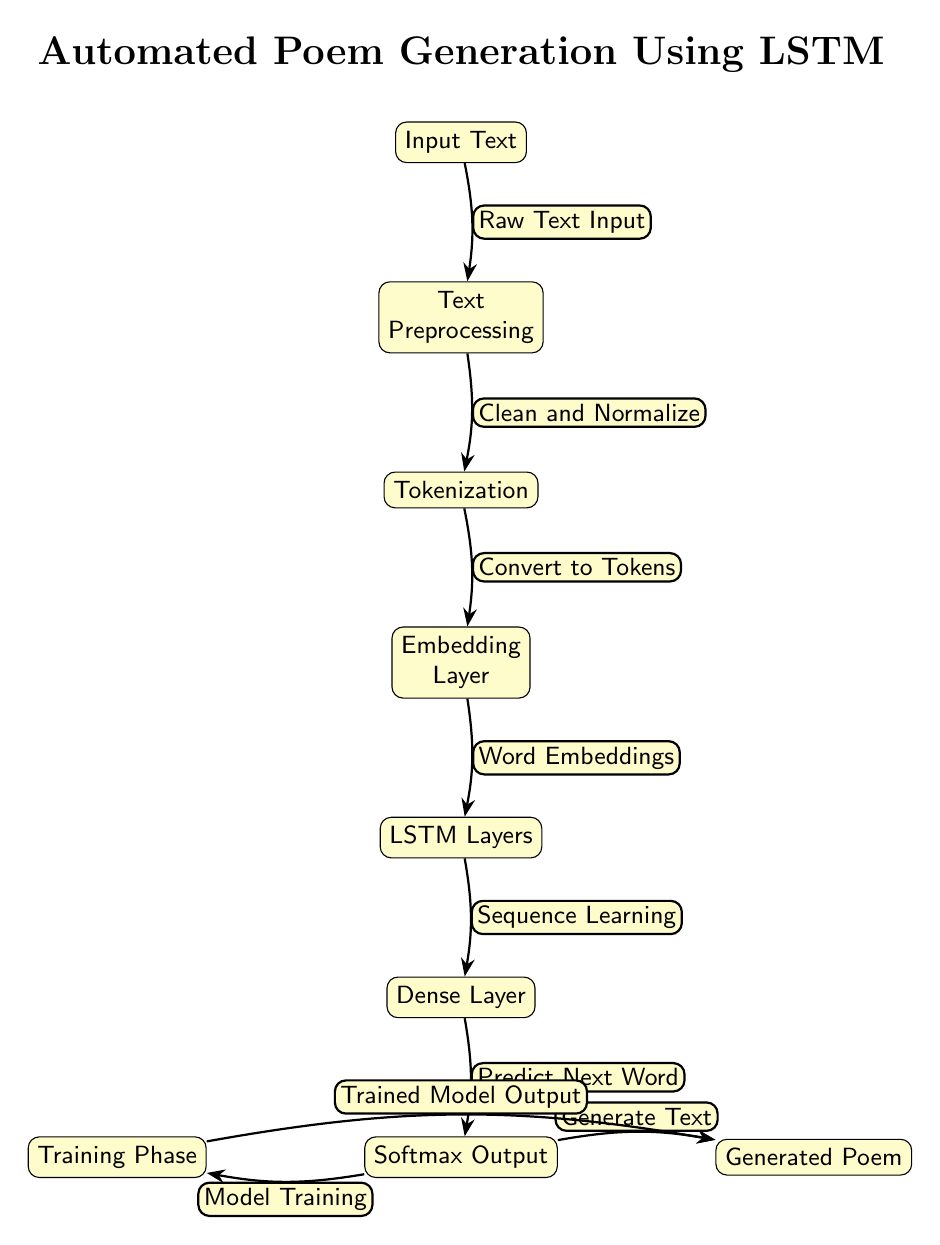What is the first step in the diagram? The diagram shows the flow starting from the "Input Text" node at the top as the first step in the process.
Answer: Input Text How many nodes are present in the diagram? Counting each distinct node from "Input Text" to "Generated Poem", there are a total of 7 nodes in the diagram.
Answer: 7 What is the output of the dense layer? The dense layer's output is directed towards the "Softmax Output" node, which predicts the next word based on the sequence processed.
Answer: Softmax Output What does the training phase output? According to the diagram, the training phase produces the "Trained Model Output" which is necessary for generating the poem.
Answer: Trained Model Output What is the relationship between the embedding layer and the lstm layers? The arrow connecting the embedding layer to the lstm layers indicates that the output of the embedding layer is used as input for the lstm layers, hence showing a flow of data.
Answer: Word Embeddings What is the final result of the automated poem generation process? The final result, as indicated by the diagram, is the "Generated Poem" which concludes the sequence of processing steps.
Answer: Generated Poem What action is taken during the text preprocessing step? The text preprocessing step is responsible for cleaning and normalizing the raw text input, preparing it for further processing stages.
Answer: Clean and Normalize What type of layer follows the lstm layers in this process? The dense layer is the next step following the lstm layers, indicating that it takes the processed sequences for further predictions.
Answer: Dense Layer How does the softmax output contribute to poem generation? The softmax output predicts the next word based on learned patterns and generates text as a final step toward producing the poem.
Answer: Generate Text 